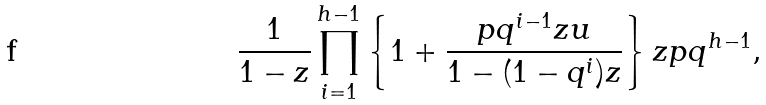<formula> <loc_0><loc_0><loc_500><loc_500>\frac { 1 } { 1 - z } \prod _ { i = 1 } ^ { h - 1 } \left \{ 1 + \frac { p q ^ { i - 1 } z u } { 1 - ( 1 - q ^ { i } ) z } \right \} z p q ^ { h - 1 } ,</formula> 